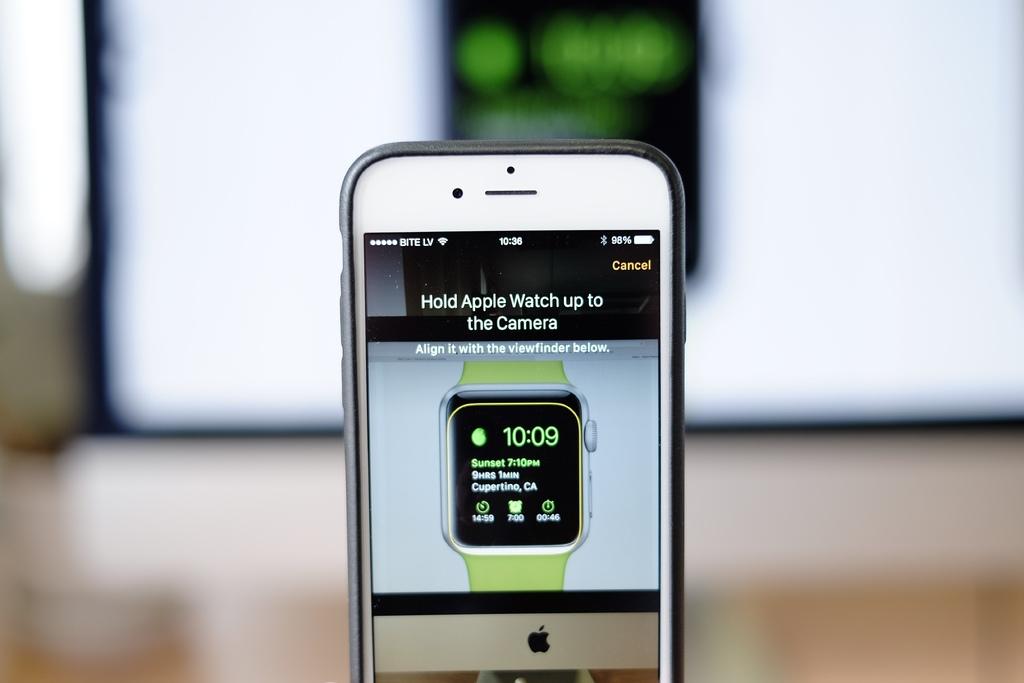Where should you hold the apple watch?
Provide a succinct answer. Up to the camera. What time is on the watch?
Give a very brief answer. 10:09. 